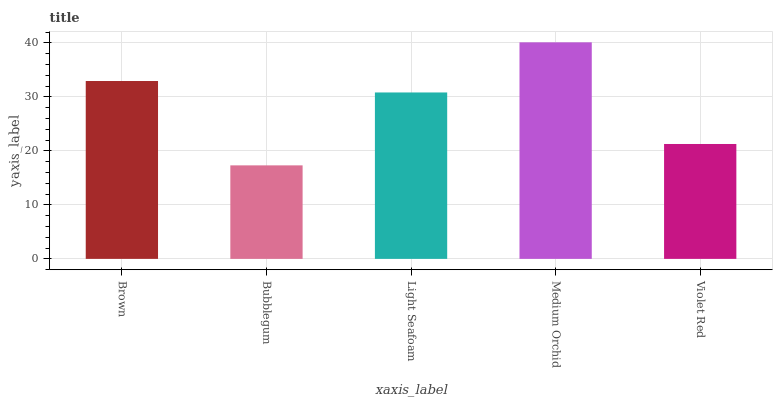Is Bubblegum the minimum?
Answer yes or no. Yes. Is Medium Orchid the maximum?
Answer yes or no. Yes. Is Light Seafoam the minimum?
Answer yes or no. No. Is Light Seafoam the maximum?
Answer yes or no. No. Is Light Seafoam greater than Bubblegum?
Answer yes or no. Yes. Is Bubblegum less than Light Seafoam?
Answer yes or no. Yes. Is Bubblegum greater than Light Seafoam?
Answer yes or no. No. Is Light Seafoam less than Bubblegum?
Answer yes or no. No. Is Light Seafoam the high median?
Answer yes or no. Yes. Is Light Seafoam the low median?
Answer yes or no. Yes. Is Brown the high median?
Answer yes or no. No. Is Brown the low median?
Answer yes or no. No. 